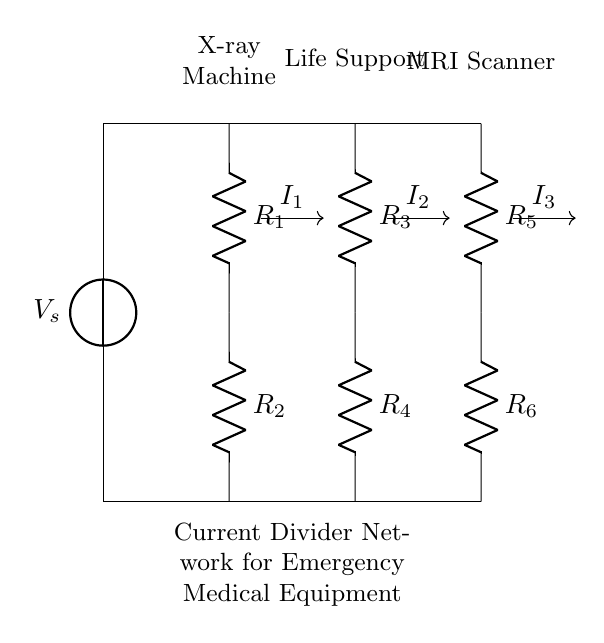What is the total number of resistors in the circuit? There are six resistors labeled R1, R2, R3, R4, R5, and R6 in the circuit diagram.
Answer: six What type of medical equipment is connected to R4? R4 is connected to the Life Support equipment as indicated by the labeling above that resistor.
Answer: Life Support What is the function of the current divider in this circuit? A current divider allows the input current to be divided among the parallel resistors, such that the current flowing through each resistor depends on its resistance value.
Answer: Distributing current Which resistor has the highest resistance? The circuit does not provide explicit resistance values for the resistors, but the current through each branch is determined by their resistance. Therefore, without values, no specific resistor can be identified as highest.
Answer: Unknown If the supply voltage is 120V, what is the voltage across each resistor? In a current divider, the voltage across each resistor is the same as the supply voltage because they are connected in parallel, making the voltage across each resistor equal to the source voltage.
Answer: 120V What happens to the current in R2 if R1 is reduced? If R1 is reduced, the total resistance of the circuit decreases, leading to an increase in total current. Since R2 is part of the current divider, it would experience a shift in current distribution depending on its resistance relative to R1.
Answer: Increases How does the current divide among R1, R2, and R3? The current divides among the resistors according to the formula I = V/R, where V is the voltage across the parallel branches. The current in each branch will be inversely proportional to its resistance, hence lower resistance will carry more current.
Answer: Inversely proportional 